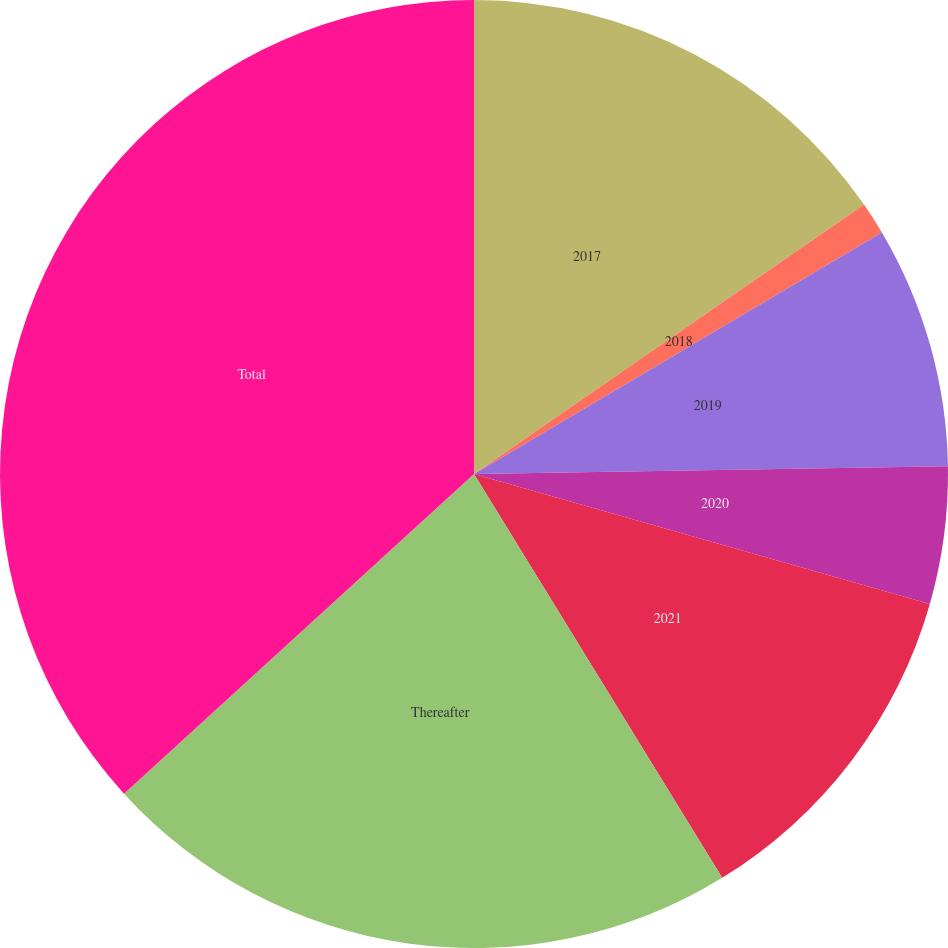Convert chart. <chart><loc_0><loc_0><loc_500><loc_500><pie_chart><fcel>2017<fcel>2018<fcel>2019<fcel>2020<fcel>2021<fcel>Thereafter<fcel>Total<nl><fcel>15.38%<fcel>1.11%<fcel>8.25%<fcel>4.68%<fcel>11.81%<fcel>21.99%<fcel>36.78%<nl></chart> 